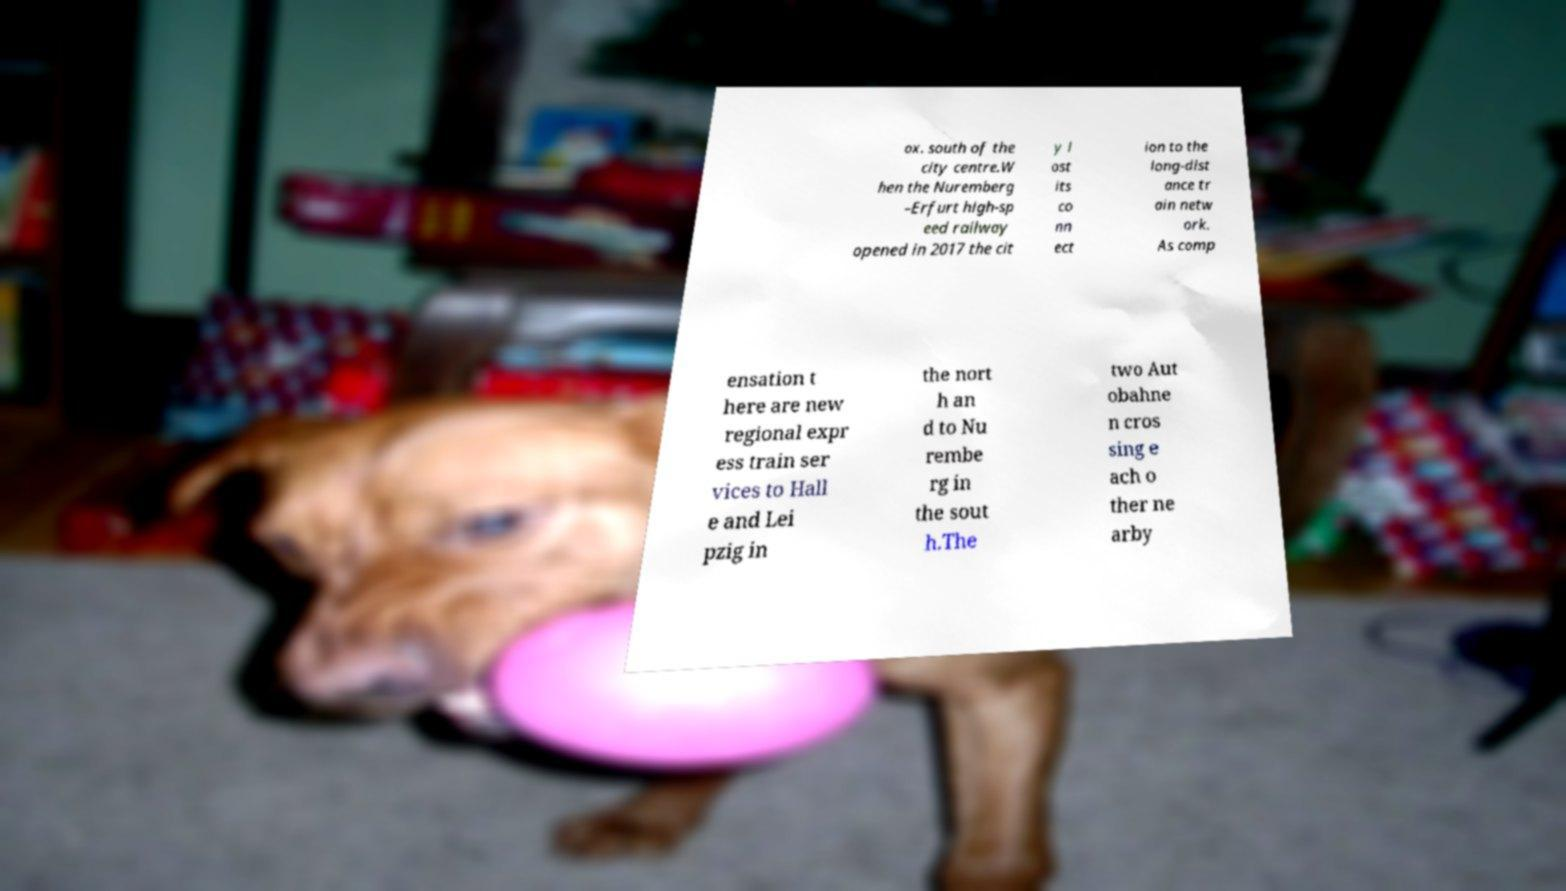Please read and relay the text visible in this image. What does it say? ox. south of the city centre.W hen the Nuremberg –Erfurt high-sp eed railway opened in 2017 the cit y l ost its co nn ect ion to the long-dist ance tr ain netw ork. As comp ensation t here are new regional expr ess train ser vices to Hall e and Lei pzig in the nort h an d to Nu rembe rg in the sout h.The two Aut obahne n cros sing e ach o ther ne arby 